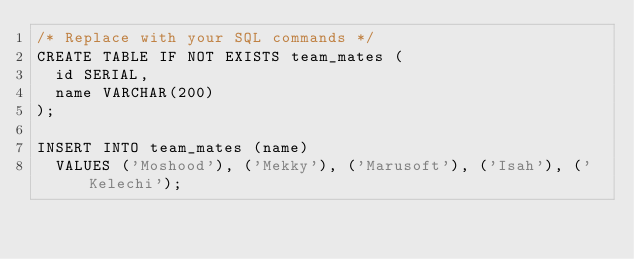<code> <loc_0><loc_0><loc_500><loc_500><_SQL_>/* Replace with your SQL commands */
CREATE TABLE IF NOT EXISTS team_mates (
	id SERIAL,
	name VARCHAR(200)
);

INSERT INTO team_mates (name)
	VALUES ('Moshood'), ('Mekky'), ('Marusoft'), ('Isah'), ('Kelechi');
</code> 